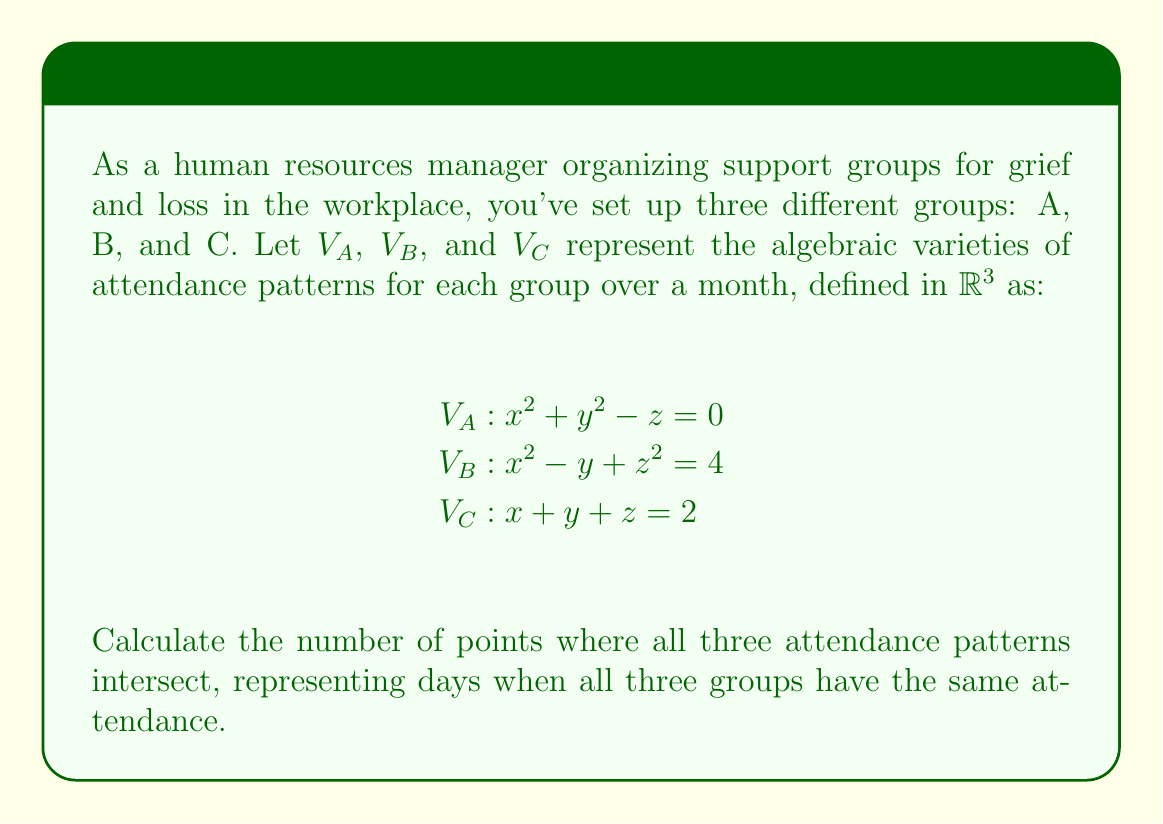What is the answer to this math problem? To find the intersection of these three algebraic varieties, we need to solve the system of equations:

1) $x^2 + y^2 - z = 0$
2) $x^2 - y + z^2 = 4$
3) $x + y + z = 2$

Let's approach this step-by-step:

Step 1: From equation 3, we can express z in terms of x and y:
$z = 2 - x - y$

Step 2: Substitute this into equation 1:
$x^2 + y^2 - (2 - x - y) = 0$
$x^2 + y^2 + x + y - 2 = 0$ ... (4)

Step 3: Substitute z into equation 2:
$x^2 - y + (2 - x - y)^2 = 4$
$x^2 - y + (4 - 4x - 4y + x^2 + 2xy + y^2) = 4$
$2x^2 + y^2 + 2xy - 5y - 4x = 0$ ... (5)

Step 4: Now we have two equations (4 and 5) in x and y. Subtract equation 4 from 5:
$(2x^2 + y^2 + 2xy - 5y - 4x) - (x^2 + y^2 + x + y - 2) = 0$
$x^2 + 2xy - 6y - 5x + 2 = 0$
$(x + 2y - 1)(x - 3) = 0$

This gives us two cases:
Case 1: $x + 2y - 1 = 0$ or
Case 2: $x = 3$

Step 5: Let's solve Case 1 first:
From $x + 2y - 1 = 0$, we get $x = 1 - 2y$
Substituting this into equation 4:
$(1 - 2y)^2 + y^2 + (1 - 2y) + y - 2 = 0$
$1 - 4y + 4y^2 + y^2 + 1 - 2y + y - 2 = 0$
$5y^2 - 5y - 1 = 0$
$y = 1$ or $y = -\frac{1}{5}$

If $y = 1$, then $x = -1$ and $z = 2$
If $y = -\frac{1}{5}$, then $x = \frac{7}{5}$ and $z = \frac{4}{5}$

Step 6: Now for Case 2, where $x = 3$:
Substituting into equation 4:
$9 + y^2 + 3 + y - 2 = 0$
$y^2 + y - 10 = 0$
$y = -\frac{5}{2}$ or $y = 2$

If $y = -\frac{5}{2}$, then $z = \frac{3}{2}$
If $y = 2$, then $z = -3$ (which doesn't satisfy equation 3)

Therefore, we have found three points of intersection:
$(-1, 1, 2)$, $(\frac{7}{5}, -\frac{1}{5}, \frac{4}{5})$, and $(3, -\frac{5}{2}, \frac{3}{2})$
Answer: 3 